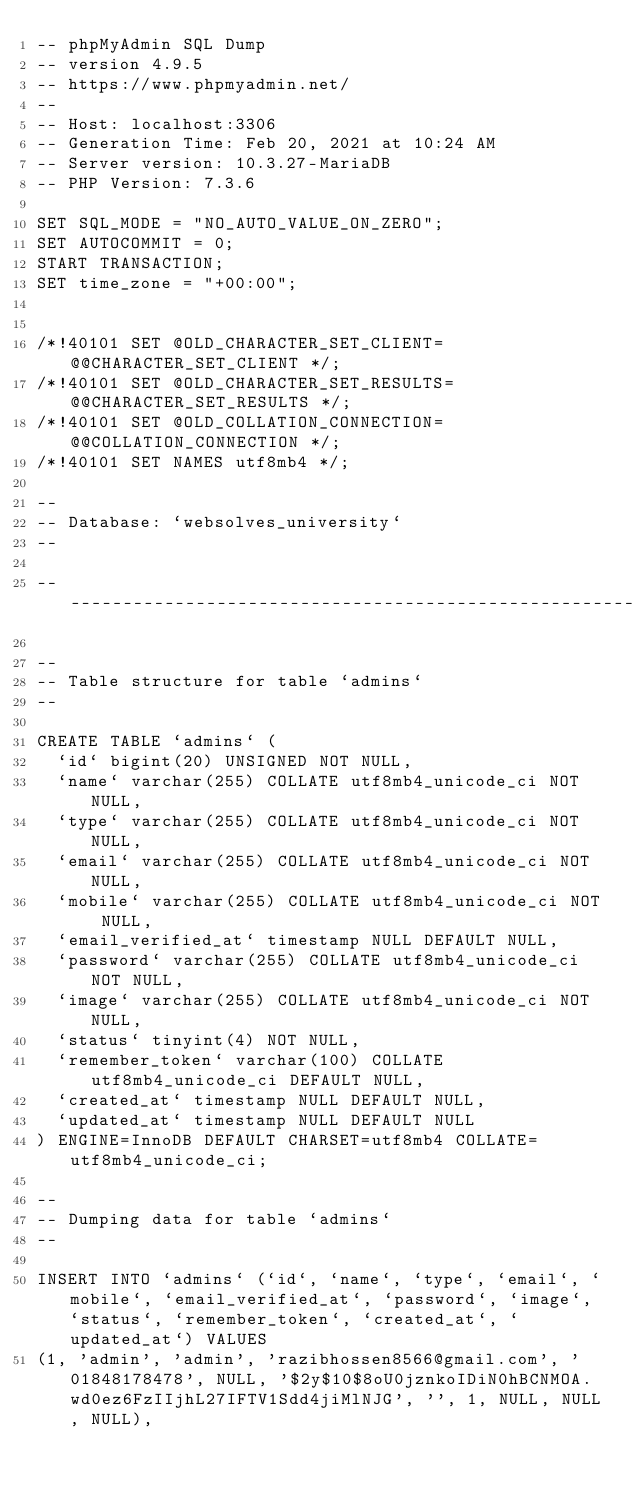<code> <loc_0><loc_0><loc_500><loc_500><_SQL_>-- phpMyAdmin SQL Dump
-- version 4.9.5
-- https://www.phpmyadmin.net/
--
-- Host: localhost:3306
-- Generation Time: Feb 20, 2021 at 10:24 AM
-- Server version: 10.3.27-MariaDB
-- PHP Version: 7.3.6

SET SQL_MODE = "NO_AUTO_VALUE_ON_ZERO";
SET AUTOCOMMIT = 0;
START TRANSACTION;
SET time_zone = "+00:00";


/*!40101 SET @OLD_CHARACTER_SET_CLIENT=@@CHARACTER_SET_CLIENT */;
/*!40101 SET @OLD_CHARACTER_SET_RESULTS=@@CHARACTER_SET_RESULTS */;
/*!40101 SET @OLD_COLLATION_CONNECTION=@@COLLATION_CONNECTION */;
/*!40101 SET NAMES utf8mb4 */;

--
-- Database: `websolves_university`
--

-- --------------------------------------------------------

--
-- Table structure for table `admins`
--

CREATE TABLE `admins` (
  `id` bigint(20) UNSIGNED NOT NULL,
  `name` varchar(255) COLLATE utf8mb4_unicode_ci NOT NULL,
  `type` varchar(255) COLLATE utf8mb4_unicode_ci NOT NULL,
  `email` varchar(255) COLLATE utf8mb4_unicode_ci NOT NULL,
  `mobile` varchar(255) COLLATE utf8mb4_unicode_ci NOT NULL,
  `email_verified_at` timestamp NULL DEFAULT NULL,
  `password` varchar(255) COLLATE utf8mb4_unicode_ci NOT NULL,
  `image` varchar(255) COLLATE utf8mb4_unicode_ci NOT NULL,
  `status` tinyint(4) NOT NULL,
  `remember_token` varchar(100) COLLATE utf8mb4_unicode_ci DEFAULT NULL,
  `created_at` timestamp NULL DEFAULT NULL,
  `updated_at` timestamp NULL DEFAULT NULL
) ENGINE=InnoDB DEFAULT CHARSET=utf8mb4 COLLATE=utf8mb4_unicode_ci;

--
-- Dumping data for table `admins`
--

INSERT INTO `admins` (`id`, `name`, `type`, `email`, `mobile`, `email_verified_at`, `password`, `image`, `status`, `remember_token`, `created_at`, `updated_at`) VALUES
(1, 'admin', 'admin', 'razibhossen8566@gmail.com', '01848178478', NULL, '$2y$10$8oU0jznkoIDiN0hBCNMOA.wd0ez6FzIIjhL27IFTV1Sdd4jiMlNJG', '', 1, NULL, NULL, NULL),</code> 